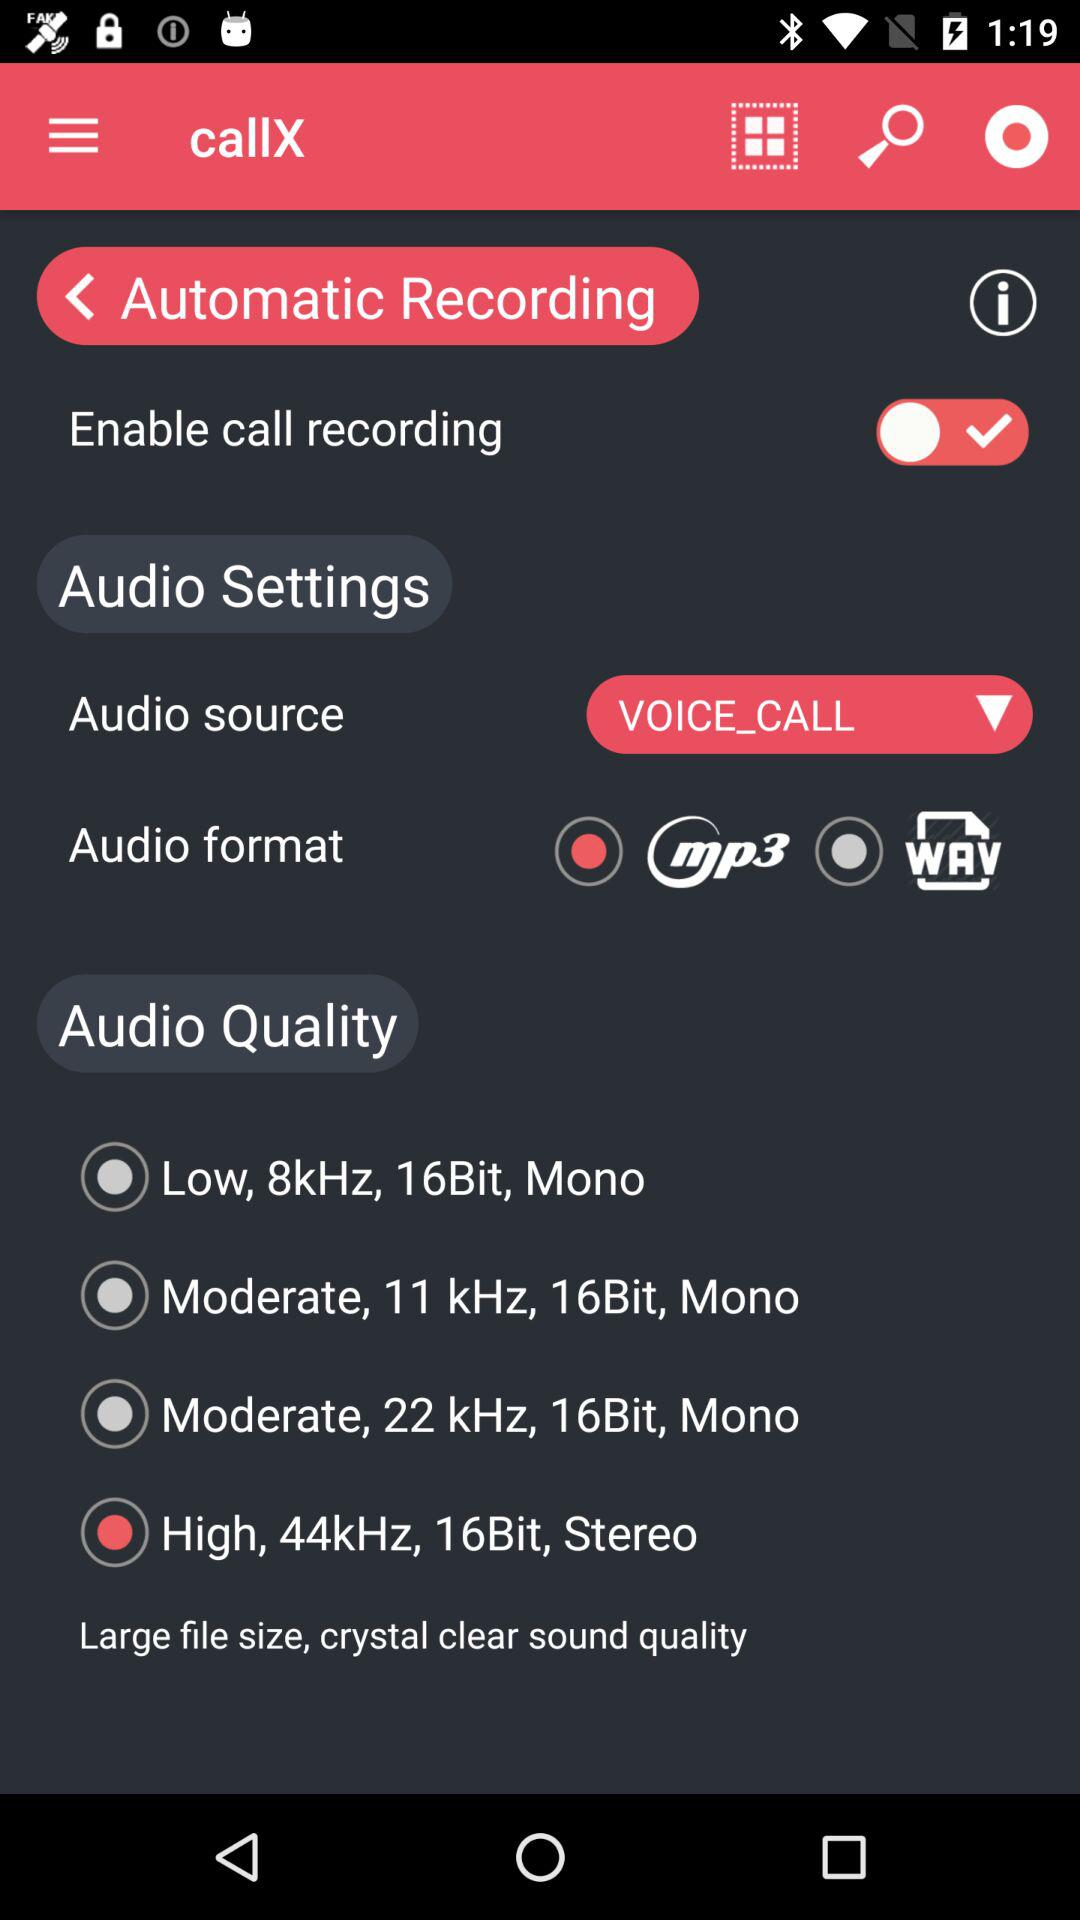What is the name of the application? The name of the application is "callX". 